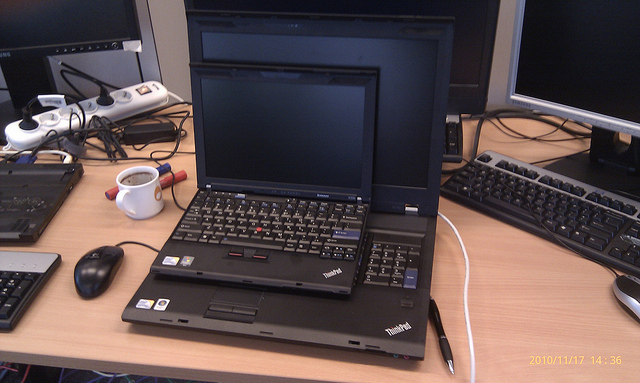Please transcribe the text in this image. 36 14 17 11 2010 